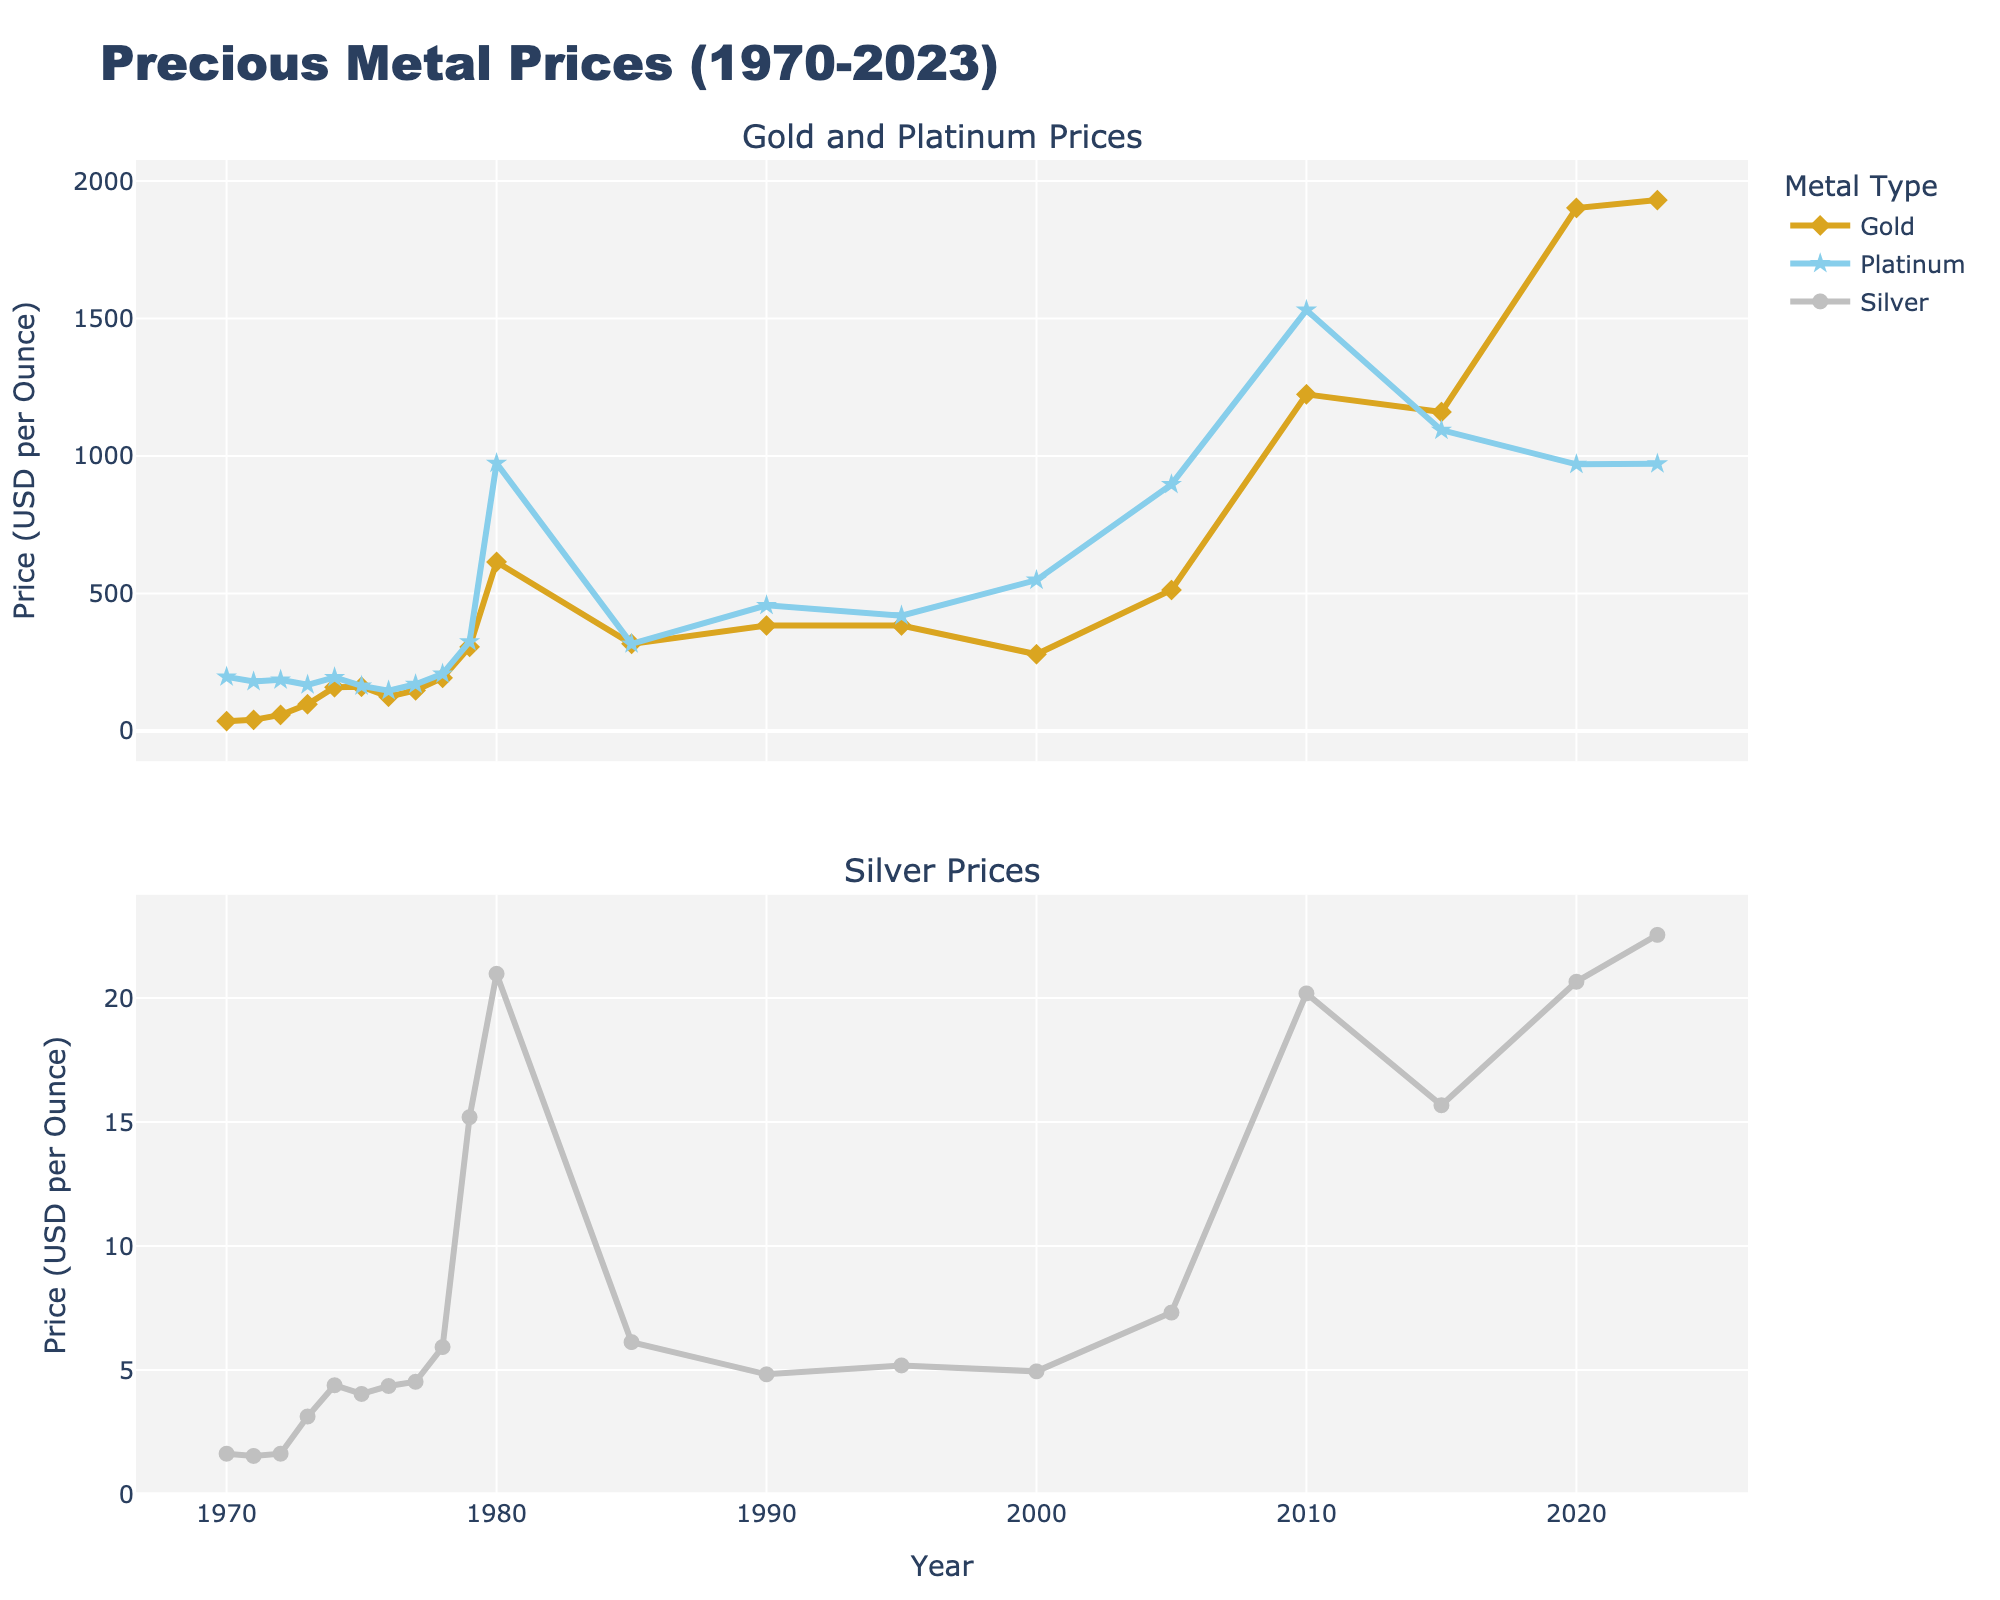What is the title of the figure? The title is usually found at the top of a chart and generally describes the main topic represented by the figure.
Answer: Precious Metal Prices (1970-2023) What are the three types of metals represented in the figure? The figure's legend indicates the different types of metals plotted, identified by distinct names and colors.
Answer: Gold, Silver, Platinum Between which years did the largest spike in gold prices occur? By observing the gold price trend (goldenrod line in the first subplot), we see a sharp rise around 1979 to 1980.
Answer: 1979-1980 Which year shows the highest price for platinum? The platinum price can be tracked using the sky blue line in the first subplot, peaking visibly in 1980.
Answer: 1980 How does the trend for silver prices compare from 1970 to 2023? In the second subplot, observing the silver price trend (silver line) from the beginning to the end shows an initial rise, peak around 1980, drop, and then slight increase towards the end.
Answer: Initial rise, peak in 1980, drop, then slight increase What was the price difference of gold between 2000 and 2010? Check the gold prices for the years 2000 (279.11) and 2010 (1224.53) and subtract them: 1224.53 - 279.11.
Answer: 945.42 USD In which year were prices of gold, silver, and platinum closest to each other? Compare the prices for each metal across all years; the prices are closest in 1970, as seen by checking each plotted point.
Answer: 1970 What trend do you observe in platinum prices from 2010 to 2023? Assess the sky blue line in the first subplot, observing platinum prices starting high in 2010, decreasing substantially by 2015, and stabilizing around the same level up to 2023.
Answer: Decline from 2010 to 2015, then stabilized Which metal experienced the greatest percentage increase from 1970 to 2023? Calculate the percentage increase for each metal: [(final price - initial price) / initial price] * 100, specifically for gold, silver, and platinum. Gold: [(1931.10 - 35.94) / 35.94]*100, Silver: [(22.55 - 1.63) / 1.63]*100, Platinum: [(972.00 - 197.00) / 197.00]*100. The highest percentage increase will be the greatest.
Answer: Gold How were the prices of gold, silver, and platinum affected by the year 1980? By scrutinizing the plots around the year 1980, each metal (gold, silver, platinum) shows a significant peak indicating a general trend of high prices for all three metals during 1980.
Answer: All peaked in 1980 